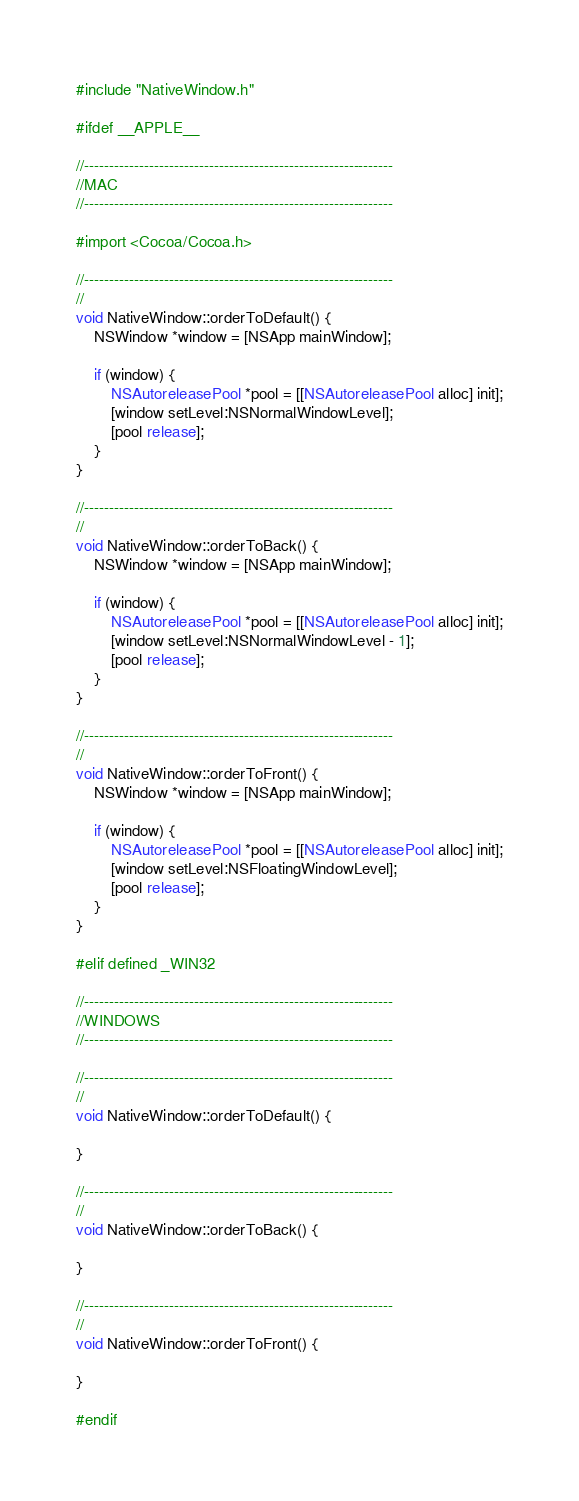Convert code to text. <code><loc_0><loc_0><loc_500><loc_500><_ObjectiveC_>#include "NativeWindow.h"

#ifdef __APPLE__

//--------------------------------------------------------------
//MAC
//--------------------------------------------------------------

#import <Cocoa/Cocoa.h>

//--------------------------------------------------------------
//
void NativeWindow::orderToDefault() {
    NSWindow *window = [NSApp mainWindow];
    
    if (window) {
        NSAutoreleasePool *pool = [[NSAutoreleasePool alloc] init];
        [window setLevel:NSNormalWindowLevel];
        [pool release];
    }
}

//--------------------------------------------------------------
//
void NativeWindow::orderToBack() {
    NSWindow *window = [NSApp mainWindow];
    
    if (window) {
        NSAutoreleasePool *pool = [[NSAutoreleasePool alloc] init];
        [window setLevel:NSNormalWindowLevel - 1];
        [pool release];
    }
}

//--------------------------------------------------------------
//
void NativeWindow::orderToFront() {
    NSWindow *window = [NSApp mainWindow];
    
    if (window) {
        NSAutoreleasePool *pool = [[NSAutoreleasePool alloc] init];
        [window setLevel:NSFloatingWindowLevel];
        [pool release];
    }
}

#elif defined _WIN32

//--------------------------------------------------------------
//WINDOWS
//--------------------------------------------------------------

//--------------------------------------------------------------
//
void NativeWindow::orderToDefault() {
    
}

//--------------------------------------------------------------
//
void NativeWindow::orderToBack() {

}

//--------------------------------------------------------------
//
void NativeWindow::orderToFront() {

}

#endif
</code> 